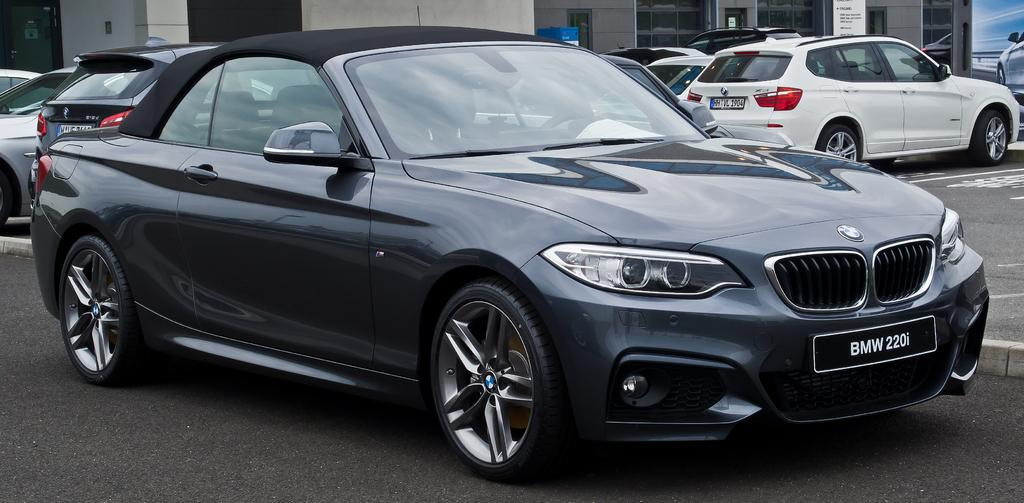What type of view is shown in the image? The image is an outside view. What can be seen on the road in the image? There are many cars on the road in the image. What is visible in the background of the image? There is a building in the background of the image. What word is written on the roof of the building in the image? There is no word written on the roof of the building in the image. How many arches can be seen on the building in the image? The image does not show any arches on the building. 